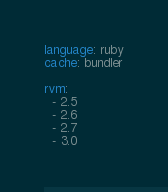Convert code to text. <code><loc_0><loc_0><loc_500><loc_500><_YAML_>language: ruby
cache: bundler

rvm:
  - 2.5
  - 2.6
  - 2.7
  - 3.0
</code> 